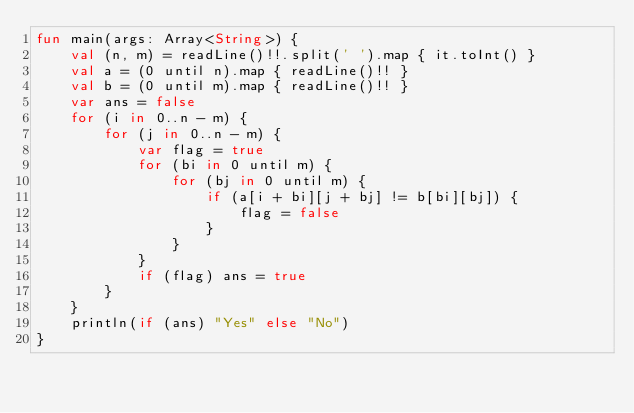<code> <loc_0><loc_0><loc_500><loc_500><_Kotlin_>fun main(args: Array<String>) {
    val (n, m) = readLine()!!.split(' ').map { it.toInt() }
    val a = (0 until n).map { readLine()!! }
    val b = (0 until m).map { readLine()!! }
    var ans = false
    for (i in 0..n - m) {
        for (j in 0..n - m) {
            var flag = true
            for (bi in 0 until m) {
                for (bj in 0 until m) {
                    if (a[i + bi][j + bj] != b[bi][bj]) {
                        flag = false
                    }
                }
            }
            if (flag) ans = true
        }
    }
    println(if (ans) "Yes" else "No")
}
</code> 